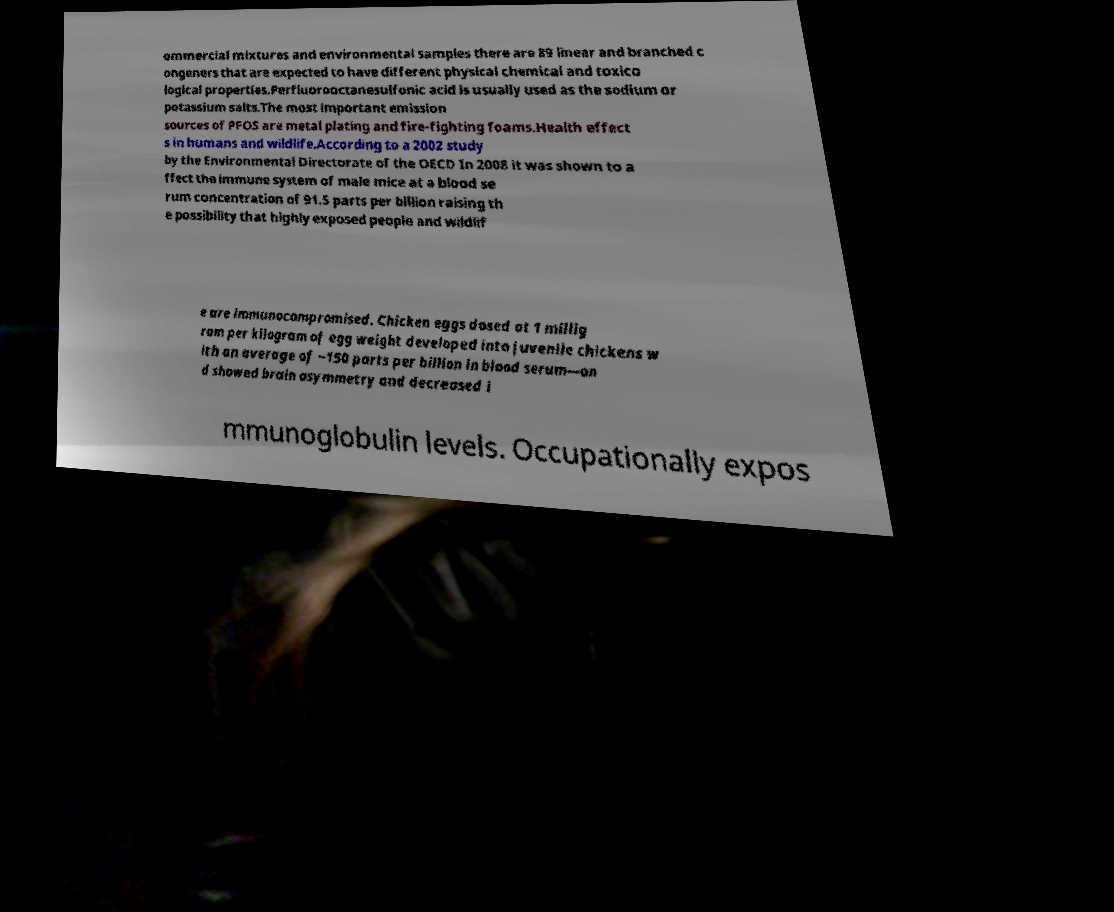Can you accurately transcribe the text from the provided image for me? ommercial mixtures and environmental samples there are 89 linear and branched c ongeners that are expected to have different physical chemical and toxico logical properties.Perfluorooctanesulfonic acid is usually used as the sodium or potassium salts.The most important emission sources of PFOS are metal plating and fire-fighting foams.Health effect s in humans and wildlife.According to a 2002 study by the Environmental Directorate of the OECD In 2008 it was shown to a ffect the immune system of male mice at a blood se rum concentration of 91.5 parts per billion raising th e possibility that highly exposed people and wildlif e are immunocompromised. Chicken eggs dosed at 1 millig ram per kilogram of egg weight developed into juvenile chickens w ith an average of ~150 parts per billion in blood serum—an d showed brain asymmetry and decreased i mmunoglobulin levels. Occupationally expos 